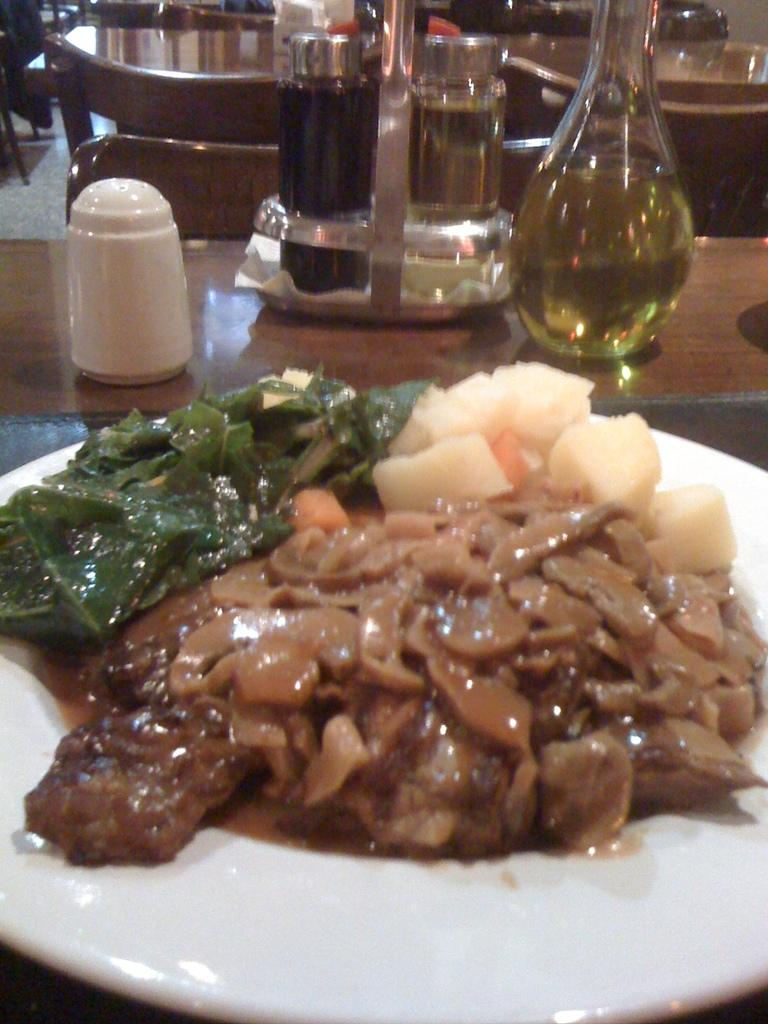What type of furniture is present in the image? There is a table in the image. What can be found on the table? The table contains some bottles. What is located at the bottom of the image? There is a plate at the bottom of the image. What is on the plate? The plate contains some food. What arithmetic problem is being solved on the plate? There is no arithmetic problem present on the plate; it contains food. What event is taking place in the image? The image does not depict a specific event; it shows a table with bottles and a plate with food. 